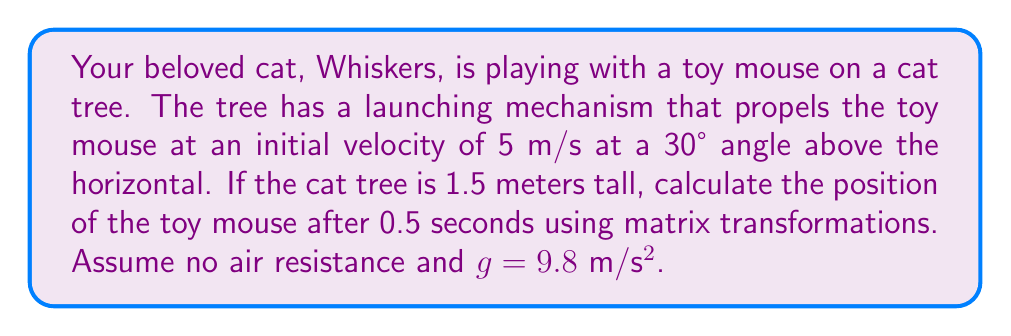Show me your answer to this math problem. Let's approach this step-by-step using matrix transformations:

1) First, we need to set up our initial position and velocity vectors:

   Initial position: $\vec{r}_0 = \begin{pmatrix} 0 \\ 1.5 \end{pmatrix}$
   Initial velocity: $\vec{v}_0 = 5 \begin{pmatrix} \cos 30° \\ \sin 30° \end{pmatrix} = \begin{pmatrix} 5\sqrt{3}/2 \\ 5/2 \end{pmatrix}$

2) The position after time t is given by:

   $\vec{r}(t) = \vec{r}_0 + \vec{v}_0t + \frac{1}{2}\vec{a}t^2$

   Where $\vec{a}$ is the acceleration due to gravity: $\vec{a} = \begin{pmatrix} 0 \\ -9.8 \end{pmatrix}$

3) We can represent this as a matrix transformation:

   $$\begin{pmatrix} x \\ y \end{pmatrix} = \begin{pmatrix} 1 & 0 \\ 0 & 1 \end{pmatrix}\begin{pmatrix} 0 \\ 1.5 \end{pmatrix} + \begin{pmatrix} t & 0 \\ 0 & t \end{pmatrix}\begin{pmatrix} 5\sqrt{3}/2 \\ 5/2 \end{pmatrix} + \frac{1}{2}\begin{pmatrix} t^2 & 0 \\ 0 & t^2 \end{pmatrix}\begin{pmatrix} 0 \\ -9.8 \end{pmatrix}$$

4) Substituting t = 0.5:

   $$\begin{pmatrix} x \\ y \end{pmatrix} = \begin{pmatrix} 0 \\ 1.5 \end{pmatrix} + \begin{pmatrix} 5\sqrt{3}/4 \\ 5/4 \end{pmatrix} + \begin{pmatrix} 0 \\ -1.225 \end{pmatrix}$$

5) Simplifying:

   $$\begin{pmatrix} x \\ y \end{pmatrix} = \begin{pmatrix} 5\sqrt{3}/4 \\ 1.525 \end{pmatrix}$$

6) Converting to decimal form:

   $$\begin{pmatrix} x \\ y \end{pmatrix} \approx \begin{pmatrix} 2.17 \\ 1.53 \end{pmatrix}$$

Therefore, after 0.5 seconds, the toy mouse will be approximately 2.17 meters horizontally from the base of the cat tree and 1.53 meters above the ground.
Answer: $(2.17, 1.53)$ meters 